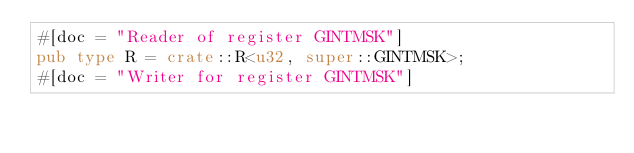<code> <loc_0><loc_0><loc_500><loc_500><_Rust_>#[doc = "Reader of register GINTMSK"]
pub type R = crate::R<u32, super::GINTMSK>;
#[doc = "Writer for register GINTMSK"]</code> 